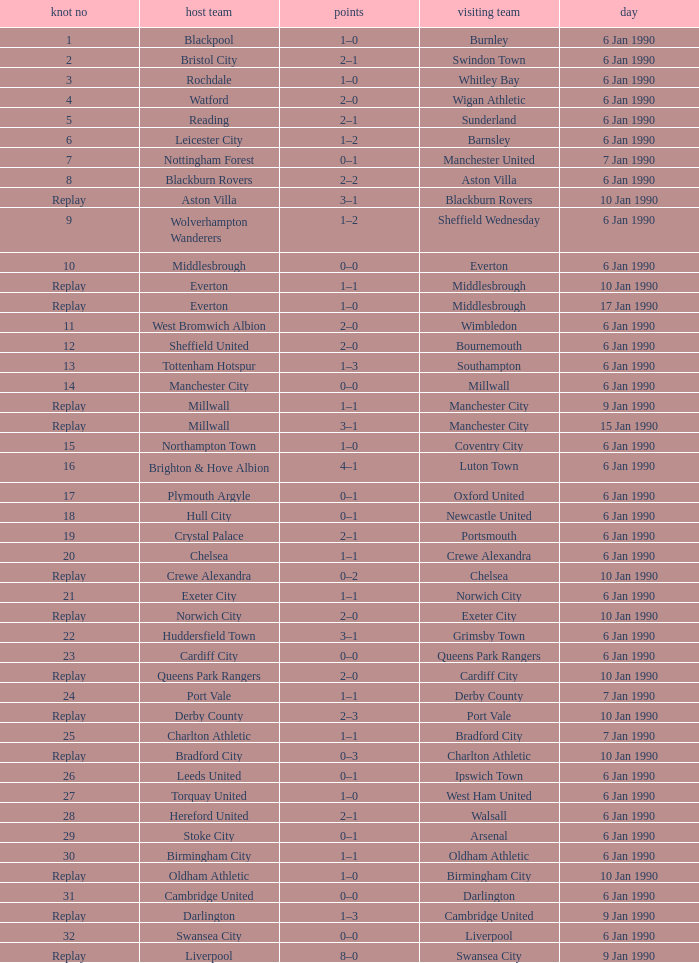What was the score of the game against away team crewe alexandra? 1–1. 